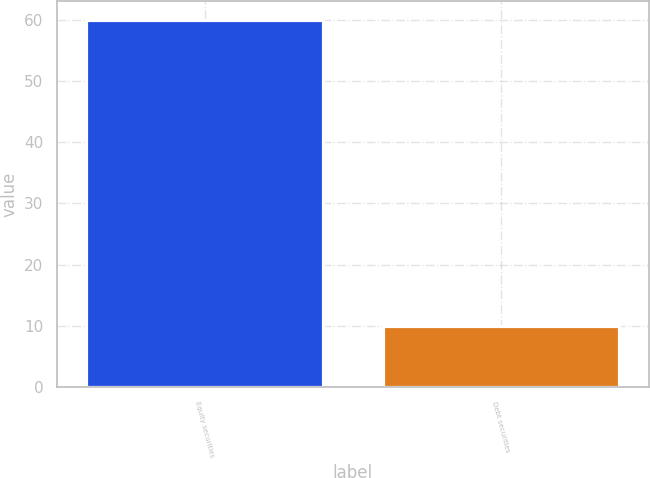Convert chart to OTSL. <chart><loc_0><loc_0><loc_500><loc_500><bar_chart><fcel>Equity securities<fcel>Debt securities<nl><fcel>60<fcel>10<nl></chart> 